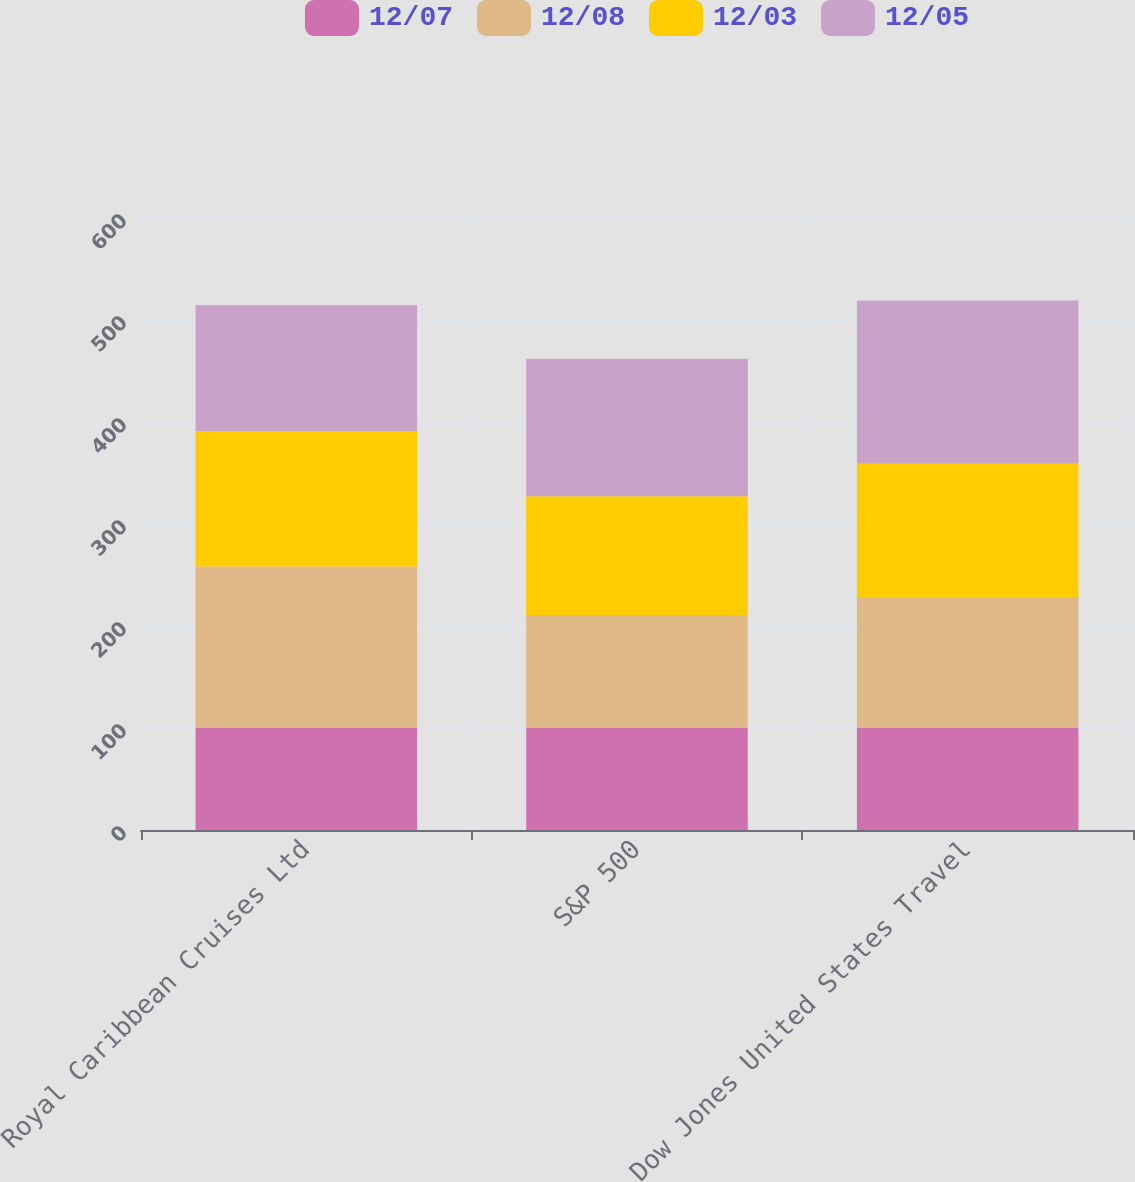<chart> <loc_0><loc_0><loc_500><loc_500><stacked_bar_chart><ecel><fcel>Royal Caribbean Cruises Ltd<fcel>S&P 500<fcel>Dow Jones United States Travel<nl><fcel>12/07<fcel>100<fcel>100<fcel>100<nl><fcel>12/08<fcel>158.32<fcel>110.88<fcel>128.53<nl><fcel>12/03<fcel>132.66<fcel>116.33<fcel>130.64<nl><fcel>12/05<fcel>123.67<fcel>134.7<fcel>159.96<nl></chart> 